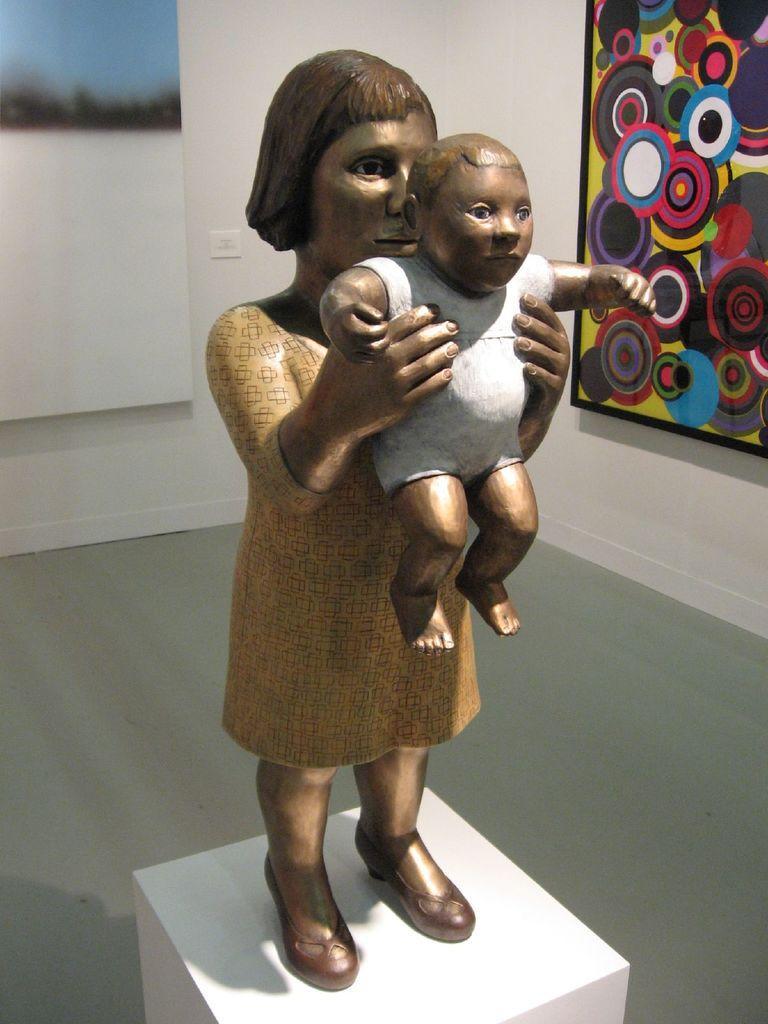Could you give a brief overview of what you see in this image? In this picture we can observe statue of a woman holding a baby in her hands. The statue is in brown color. On the right side we can observe a photo frame fixed to the wall. In the background there is a wall. 